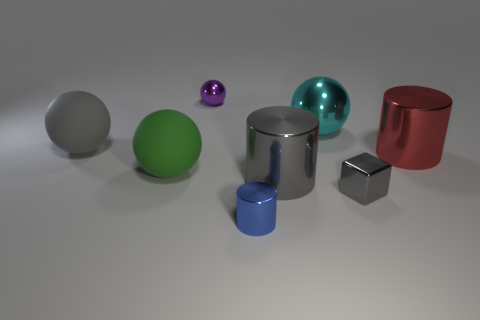Add 1 purple balls. How many objects exist? 9 Subtract all blocks. How many objects are left? 7 Add 6 matte things. How many matte things are left? 8 Add 6 tiny gray cubes. How many tiny gray cubes exist? 7 Subtract 0 purple blocks. How many objects are left? 8 Subtract all small green rubber cubes. Subtract all large green objects. How many objects are left? 7 